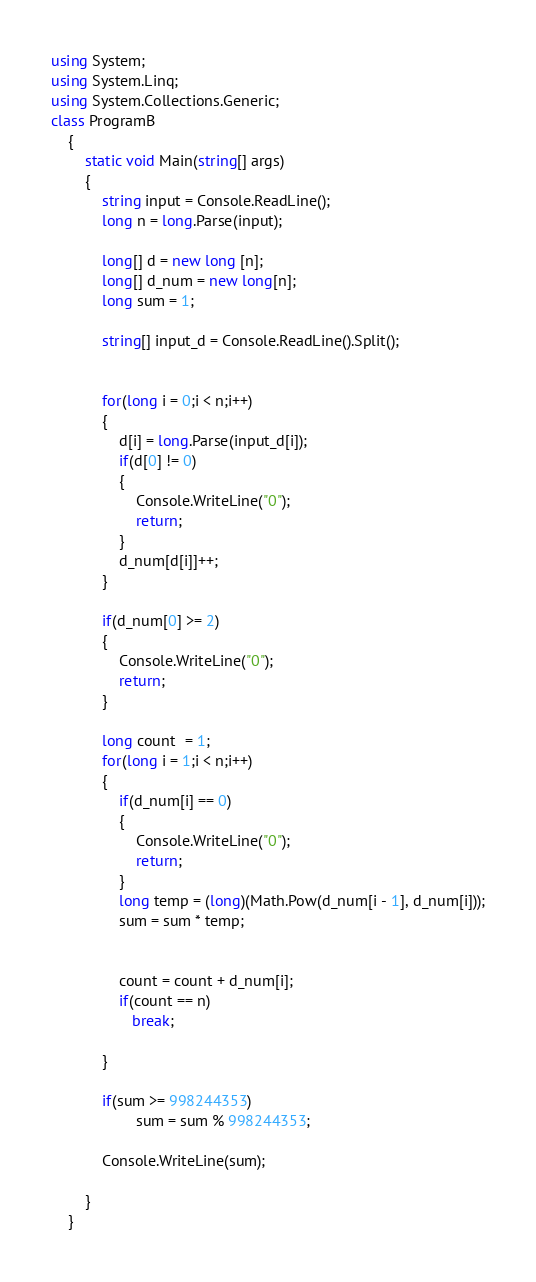<code> <loc_0><loc_0><loc_500><loc_500><_C#_>using System;
using System.Linq;
using System.Collections.Generic;
class ProgramB
    {
        static void Main(string[] args)
        {
            string input = Console.ReadLine();
            long n = long.Parse(input);

            long[] d = new long [n];
            long[] d_num = new long[n];
            long sum = 1;

            string[] input_d = Console.ReadLine().Split();


            for(long i = 0;i < n;i++)
            {
                d[i] = long.Parse(input_d[i]);
                if(d[0] != 0)
                {
                    Console.WriteLine("0");
                    return;
                }
                d_num[d[i]]++;
            }

            if(d_num[0] >= 2)
            {
                Console.WriteLine("0");
                return;
            }

            long count  = 1;
            for(long i = 1;i < n;i++)
            {
                if(d_num[i] == 0)
                {
                    Console.WriteLine("0");
                    return;
                }
                long temp = (long)(Math.Pow(d_num[i - 1], d_num[i]));
                sum = sum * temp;
                

                count = count + d_num[i];
                if(count == n)
                   break;

            }
          
            if(sum >= 998244353)
                    sum = sum % 998244353;
          
            Console.WriteLine(sum);

        }
    }</code> 